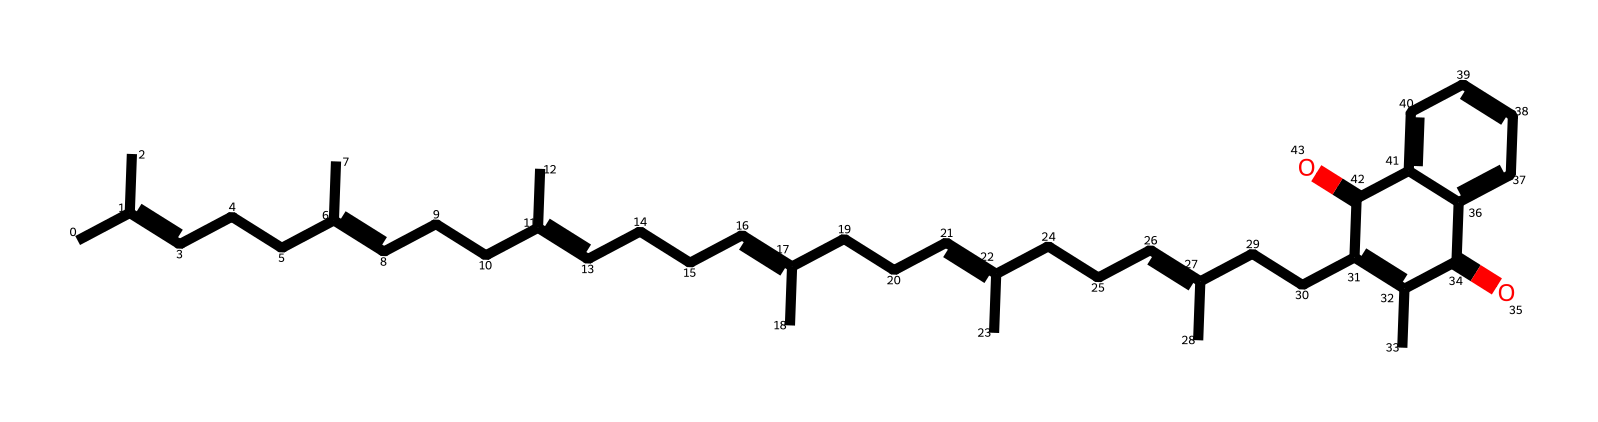What is the primary function of Vitamin K2? Vitamin K2 is primarily involved in the process of blood clotting, as it serves as a cofactor for the enzyme that converts certain proteins into their active forms, which are necessary for coagulation.
Answer: blood clotting How many double bonds are present in the molecular structure of Vitamin K2? By examining the structure given in the SMILES representation, one can identify that there are multiple carbon-carbon double bonds. Counting these reveals that there are six double bonds in the structure.
Answer: six What is the molecular formula derived from the structure of Vitamin K2? The process involves counting the carbon (C) and hydrogen (H) atoms in the structure based on the SMILES representation. After counting all the atoms, the molecular formula for Vitamin K2 is determined to be C31H46O2.
Answer: C31H46O2 Which functional groups are present in Vitamin K2? The structure depicts carbonyl groups (C=O) and also implies the presence of alkenes due to the double bonds. The carbonyl and alkenes are key functional groups present in Vitamin K2.
Answer: carbonyl, alkene How does Vitamin K2 contribute to bone health? Vitamin K2 activates osteocalcin, a protein that binds calcium to bones, thus supporting bone mineralization and health. The mechanism involves the interaction of Vitamin K2 with calcium-binding proteins.
Answer: activates osteocalcin What type of vitamin is Vitamin K2 classified as? Vitamin K2 is classified as a fat-soluble vitamin, which plays a role in the synthesis of proteins that regulate blood clotting and bone metabolism. The hydrophobic nature of its structure indicates its classification.
Answer: fat-soluble 